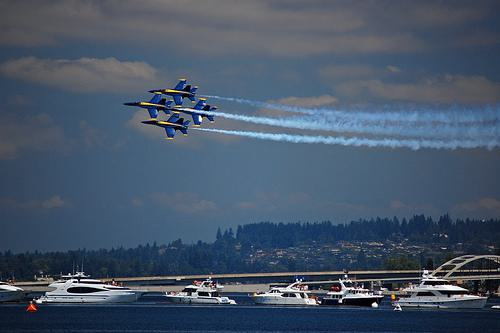How many boats are there in the image? 2 